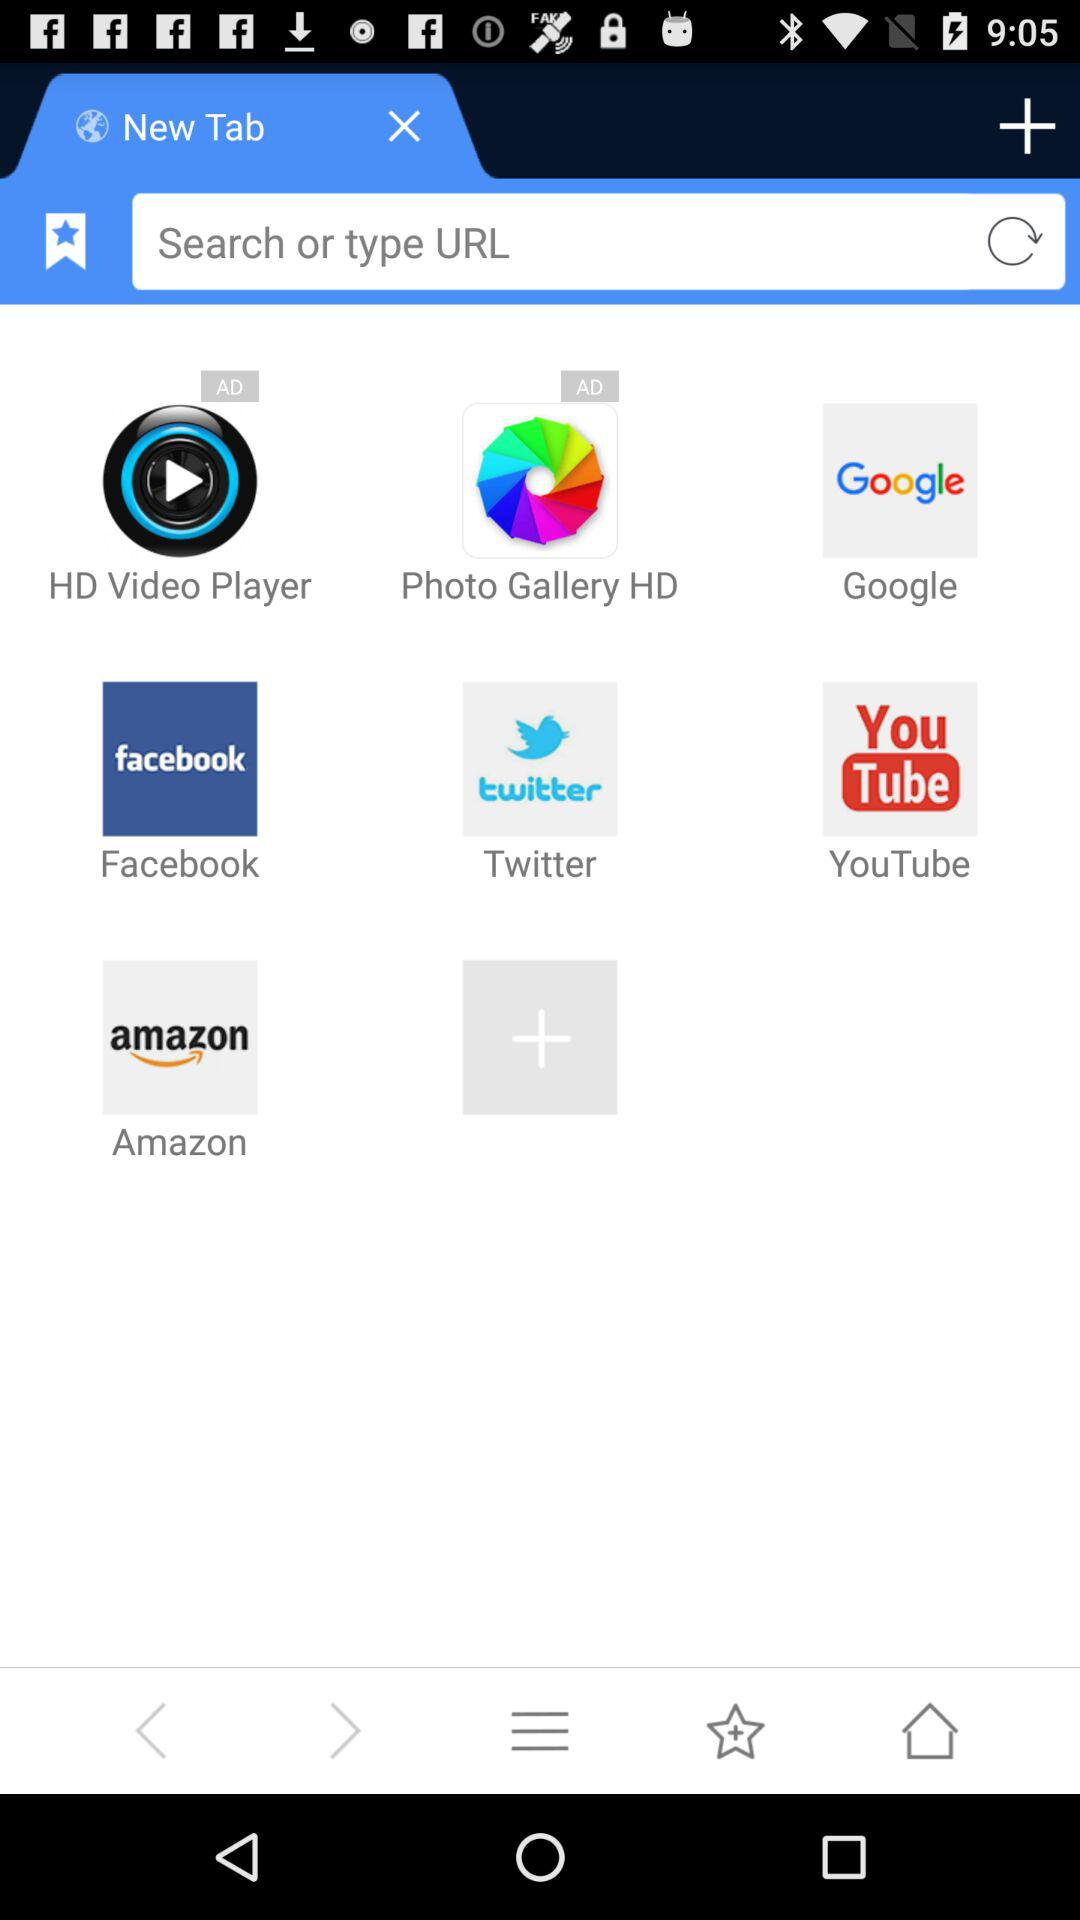What are the names of the applications that contain advertisements? The names of the applications are "HD Video Player" and "Photo Gallery HD". 